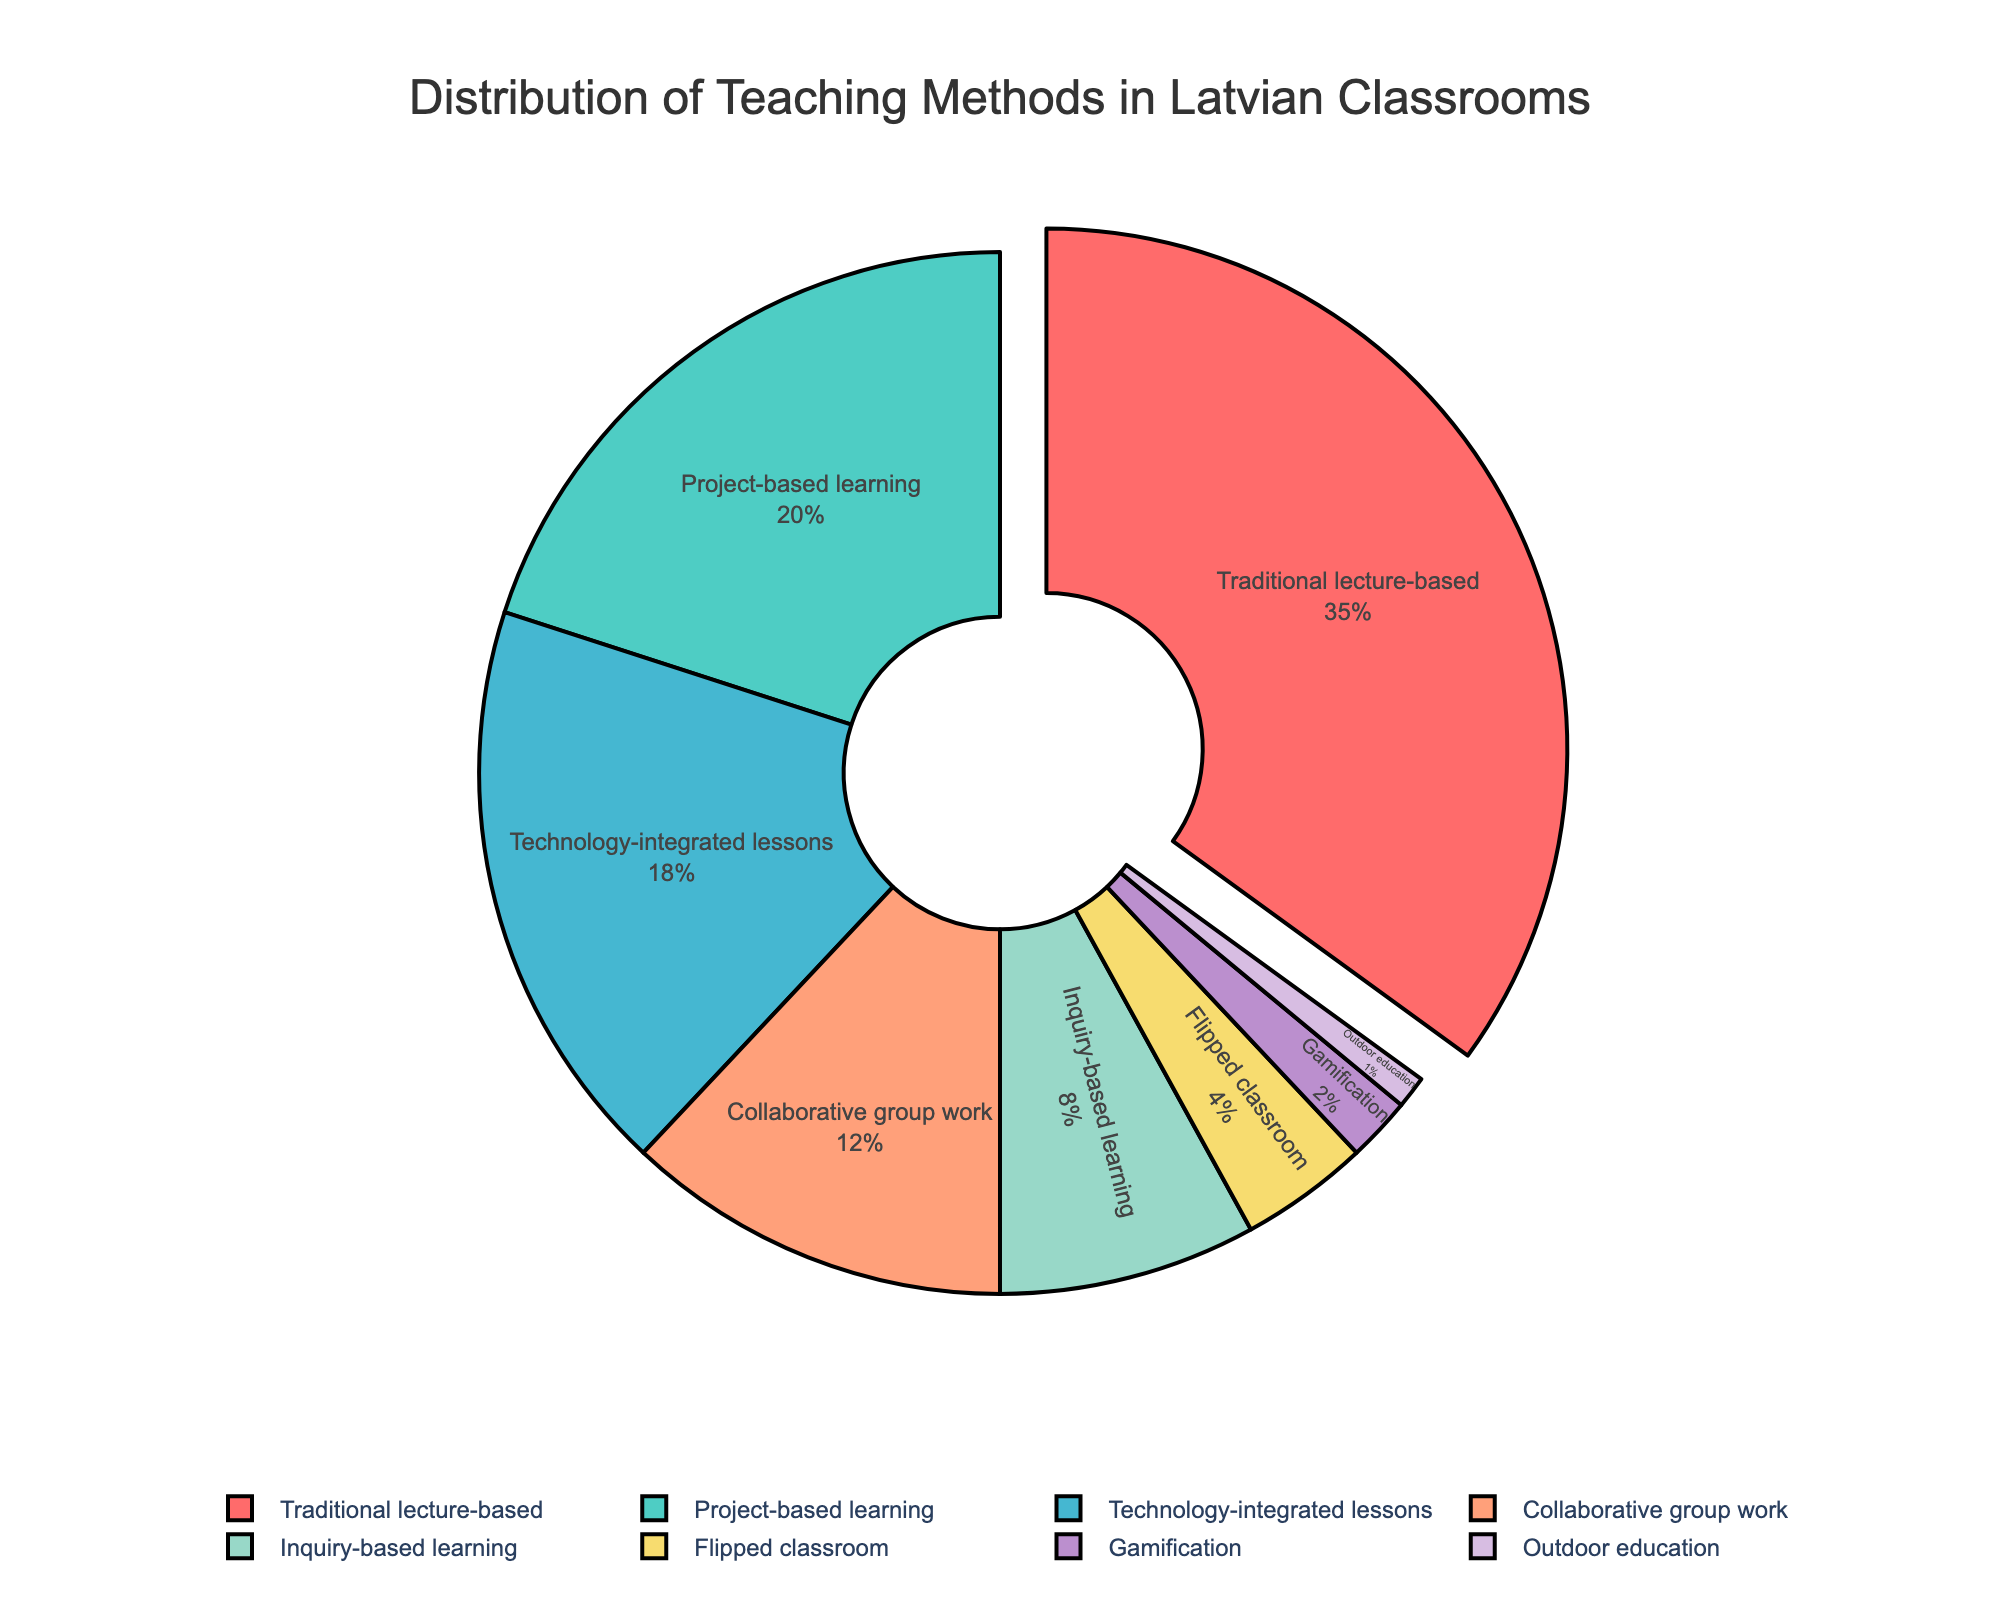What is the most commonly used teaching method in Latvian classrooms? By looking at the pie chart, identify the segment representing the largest percentage. The traditional lecture-based method occupies 35% of the chart, which is the largest single segment.
Answer: Traditional lecture-based What is the combined percentage of technology-integrated lessons and flipped classroom? Identify the percentages for both technology-integrated lessons and flipped classroom from the pie chart, then add them together: 18% + 4% = 22%.
Answer: 22% How does the percentage of project-based learning compare to that of traditional lecture-based? Observe the pie chart and compare the two values. Project-based learning is at 20%, while traditional lecture-based is at 35%. Hence, project-based learning is less common.
Answer: Project-based learning is less common Which teaching method corresponds to the green segment, and what is its percentage? Identify the green segment in the pie chart and match it to the corresponding label. The green segment represents technology-integrated lessons, which is 18%.
Answer: Technology-integrated lessons, 18% What is the percentage difference between gamification and collaborative group work? Note the percentages for both gamification and collaborative group work from the chart and calculate the difference: 12% - 2% = 10%.
Answer: 10% Is outdoor education more or less common than inquiry-based learning? Compare the segment sizes for outdoor education and inquiry-based learning on the pie chart. Outdoor education is 1%, while inquiry-based learning is 8%, indicating outdoor education is less common.
Answer: Outdoor education is less common What fraction of teaching methods (sum of percentages) are based on engaging students actively (project-based learning, technology-integrated lessons, collaborative group work, inquiry-based learning, gamification, outdoor education)? Add the percentages for active-engagement methods from the chart: 20% + 18% + 12% + 8% + 2% + 1% = 61%.
Answer: 61% Which teaching methods are under 10% in usage? List the segments of the pie chart with less than 10% each. These include inquiry-based learning (8%), flipped classroom (4%), gamification (2%), and outdoor education (1%).
Answer: Inquiry-based learning, flipped classroom, gamification, outdoor education 